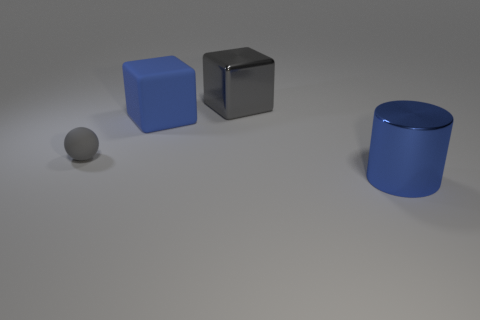Is there a yellow block made of the same material as the gray ball?
Offer a terse response. No. Is there a gray sphere that is in front of the block that is on the left side of the large metallic object that is to the left of the blue cylinder?
Your response must be concise. Yes. There is a small gray ball; are there any gray rubber objects right of it?
Ensure brevity in your answer.  No. Are there any big rubber cylinders of the same color as the shiny cylinder?
Offer a very short reply. No. How many tiny things are shiny spheres or blocks?
Your answer should be very brief. 0. Is the material of the blue object that is on the left side of the large blue cylinder the same as the gray cube?
Make the answer very short. No. The big object behind the blue matte cube behind the blue object in front of the large rubber block is what shape?
Provide a succinct answer. Cube. How many gray objects are either small things or large cubes?
Your answer should be compact. 2. Are there an equal number of tiny gray balls behind the gray metallic object and rubber balls in front of the metal cylinder?
Ensure brevity in your answer.  Yes. There is a big blue thing to the left of the big shiny cube; is it the same shape as the gray thing in front of the big gray shiny cube?
Provide a short and direct response. No. 